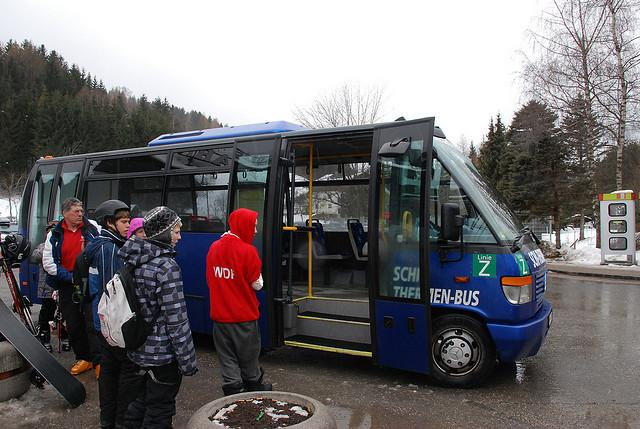Which head covering is made of the hardest material? helmet 